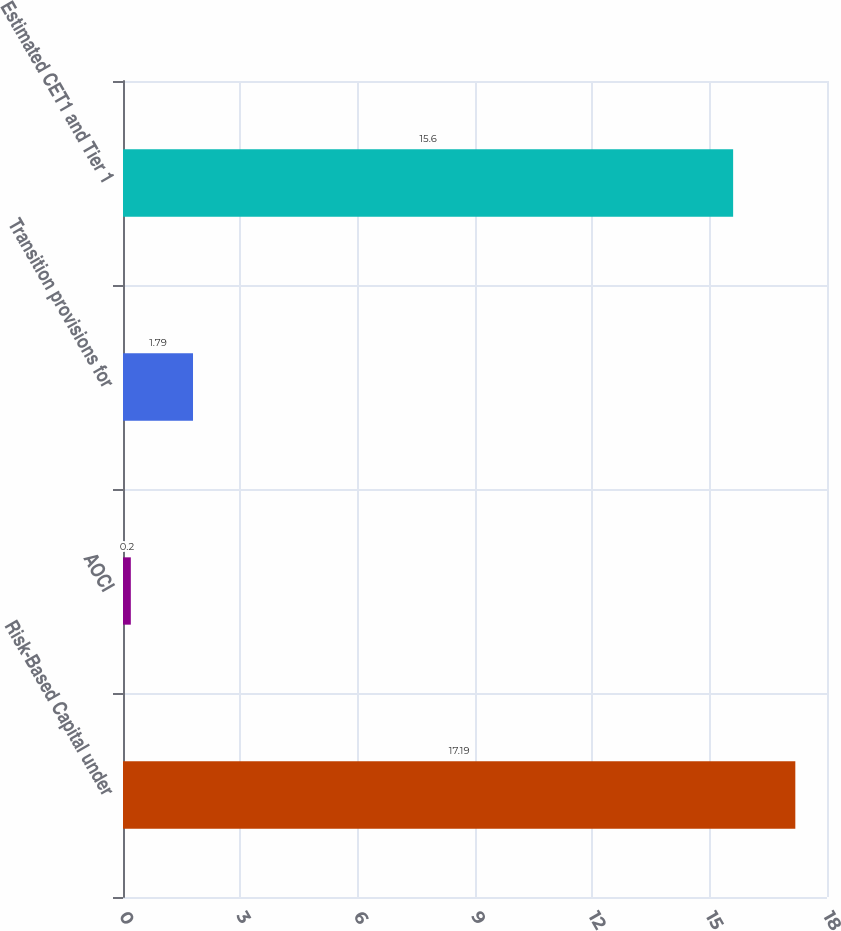<chart> <loc_0><loc_0><loc_500><loc_500><bar_chart><fcel>Risk-Based Capital under<fcel>AOCI<fcel>Transition provisions for<fcel>Estimated CET1 and Tier 1<nl><fcel>17.19<fcel>0.2<fcel>1.79<fcel>15.6<nl></chart> 